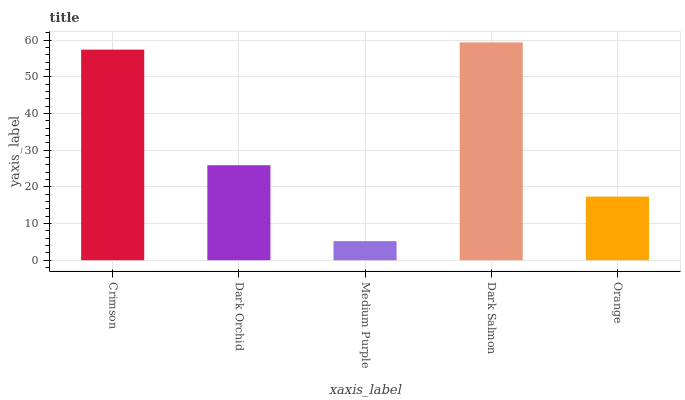Is Medium Purple the minimum?
Answer yes or no. Yes. Is Dark Salmon the maximum?
Answer yes or no. Yes. Is Dark Orchid the minimum?
Answer yes or no. No. Is Dark Orchid the maximum?
Answer yes or no. No. Is Crimson greater than Dark Orchid?
Answer yes or no. Yes. Is Dark Orchid less than Crimson?
Answer yes or no. Yes. Is Dark Orchid greater than Crimson?
Answer yes or no. No. Is Crimson less than Dark Orchid?
Answer yes or no. No. Is Dark Orchid the high median?
Answer yes or no. Yes. Is Dark Orchid the low median?
Answer yes or no. Yes. Is Crimson the high median?
Answer yes or no. No. Is Orange the low median?
Answer yes or no. No. 